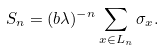<formula> <loc_0><loc_0><loc_500><loc_500>S _ { n } = ( b \lambda ) ^ { - n } \sum _ { x \in L _ { n } } \sigma _ { x } .</formula> 